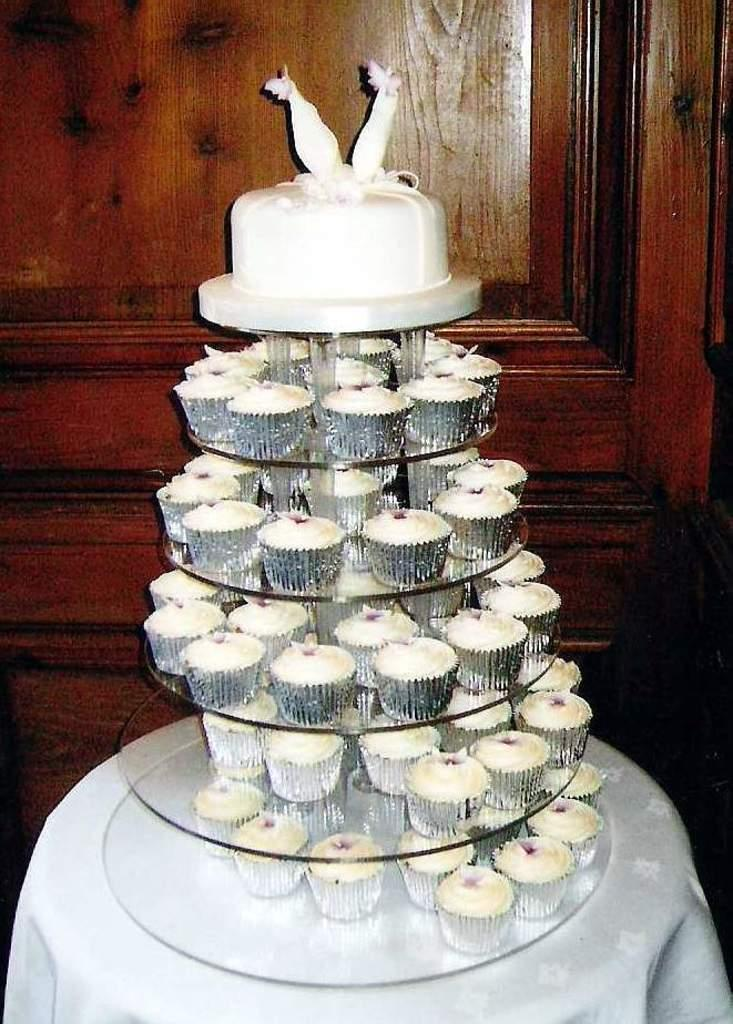What type of dessert is the main subject of the image? There is a cake in the image. What color is the cake? The cake is white in color. Are there any other desserts visible in the image? Yes, there are cupcakes in the image. Where are the cake and cupcakes located? The cake and cupcakes are on a table. What is covering the table? A white cloth is covering the table. What can be seen in the background of the image? There is a brown door visible in the background of the image. How does the orange compare to the cake in terms of size in the image? There is no orange present in the image, so it cannot be compared to the cake in terms of size. 